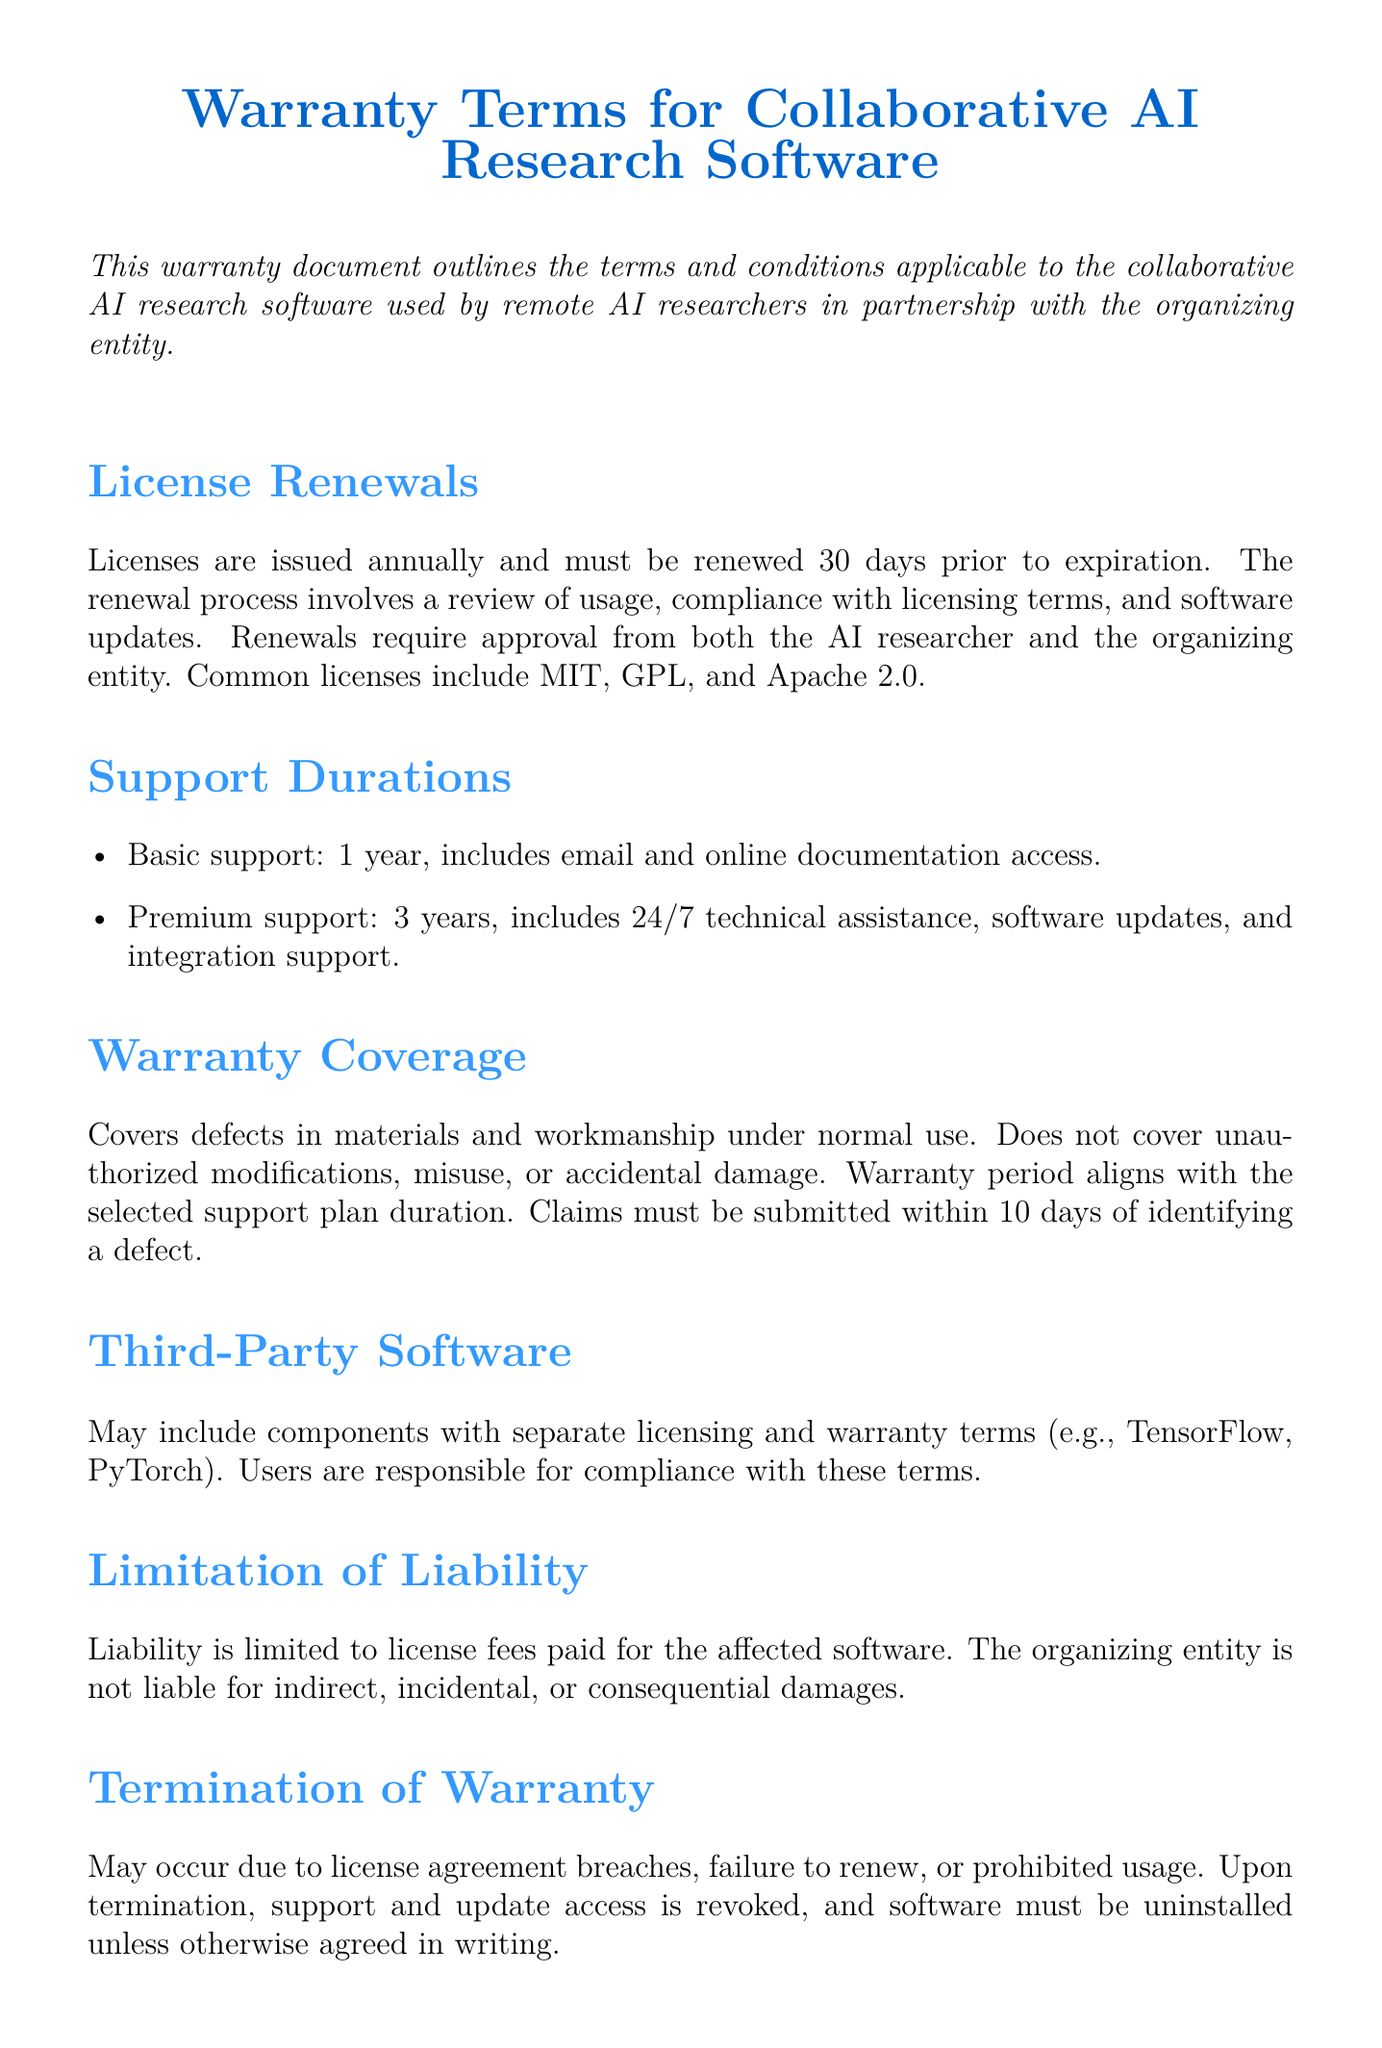What is the warranty period for basic support? The document states that basic support lasts for one year.
Answer: 1 year How many days prior to expiration must licenses be renewed? The renewal process requires completion 30 days before the license expiration.
Answer: 30 days What kind of technical assistance is included in premium support? Premium support offers 24/7 technical assistance among other services.
Answer: 24/7 technical assistance What must be submitted within 10 days of identifying a defect? Claims for warranty coverage must be submitted within this time frame.
Answer: Claims What happens upon termination of the warranty? The warranty document states that support and update access is revoked, and software must be uninstalled unless otherwise agreed.
Answer: Support and update access is revoked What type of damages is the organizing entity not liable for? The document specifies liability limitations concerning indirect, incidental, or consequential damages.
Answer: Indirect, incidental, or consequential damages How long is the warranty period related to the support plan? The warranty period aligns with the duration selected for the support plan.
Answer: Aligns with support plan duration What components may have separate licensing and warranty terms? The document mentions third-party software that includes separate terms.
Answer: Third-party software Which types of licenses are mentioned in the document? Common licenses listed include MIT, GPL, and Apache 2.0.
Answer: MIT, GPL, Apache 2.0 